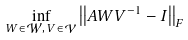Convert formula to latex. <formula><loc_0><loc_0><loc_500><loc_500>\inf _ { W \in \mathcal { W } , \, V \in \mathcal { V } } \left | \left | A W V ^ { - 1 } - I \right | \right | _ { F }</formula> 